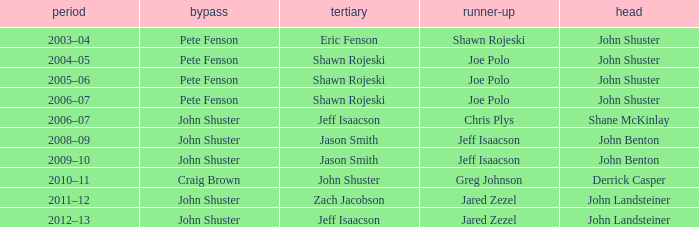Which season has Zach Jacobson in third? 2011–12. Would you mind parsing the complete table? {'header': ['period', 'bypass', 'tertiary', 'runner-up', 'head'], 'rows': [['2003–04', 'Pete Fenson', 'Eric Fenson', 'Shawn Rojeski', 'John Shuster'], ['2004–05', 'Pete Fenson', 'Shawn Rojeski', 'Joe Polo', 'John Shuster'], ['2005–06', 'Pete Fenson', 'Shawn Rojeski', 'Joe Polo', 'John Shuster'], ['2006–07', 'Pete Fenson', 'Shawn Rojeski', 'Joe Polo', 'John Shuster'], ['2006–07', 'John Shuster', 'Jeff Isaacson', 'Chris Plys', 'Shane McKinlay'], ['2008–09', 'John Shuster', 'Jason Smith', 'Jeff Isaacson', 'John Benton'], ['2009–10', 'John Shuster', 'Jason Smith', 'Jeff Isaacson', 'John Benton'], ['2010–11', 'Craig Brown', 'John Shuster', 'Greg Johnson', 'Derrick Casper'], ['2011–12', 'John Shuster', 'Zach Jacobson', 'Jared Zezel', 'John Landsteiner'], ['2012–13', 'John Shuster', 'Jeff Isaacson', 'Jared Zezel', 'John Landsteiner']]} 